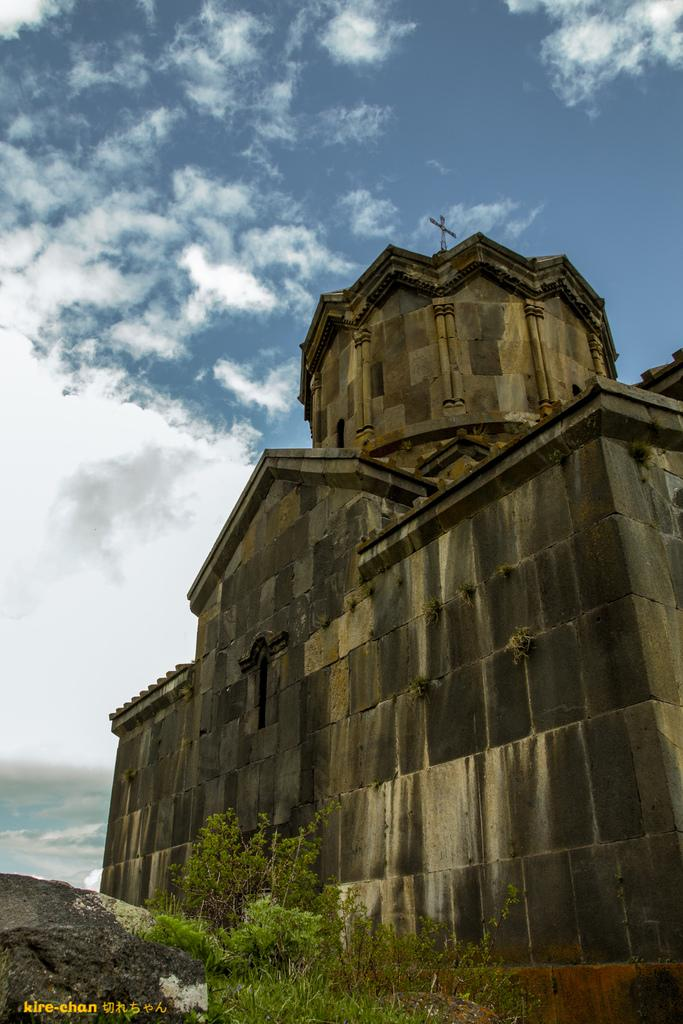What type of structure is located on the right side of the image? There is a castle on the right side of the image. What is in front of the castle? There are plants in front of the castle. What can be seen above the castle? The sky is visible above the castle. What is present in the sky? Clouds are present in the sky. What type of coat is hanging on the castle wall in the image? There is no coat present in the image; it only features a castle, plants, and clouds in the sky. 